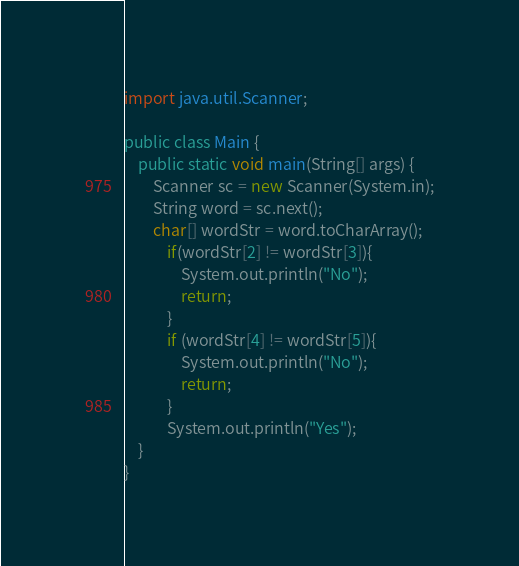Convert code to text. <code><loc_0><loc_0><loc_500><loc_500><_Java_>import java.util.Scanner;

public class Main {
    public static void main(String[] args) {
        Scanner sc = new Scanner(System.in);
        String word = sc.next();
        char[] wordStr = word.toCharArray();
            if(wordStr[2] != wordStr[3]){
                System.out.println("No");
                return;
            }
            if (wordStr[4] != wordStr[5]){
                System.out.println("No");
                return;
            }
            System.out.println("Yes");
    }
}
</code> 